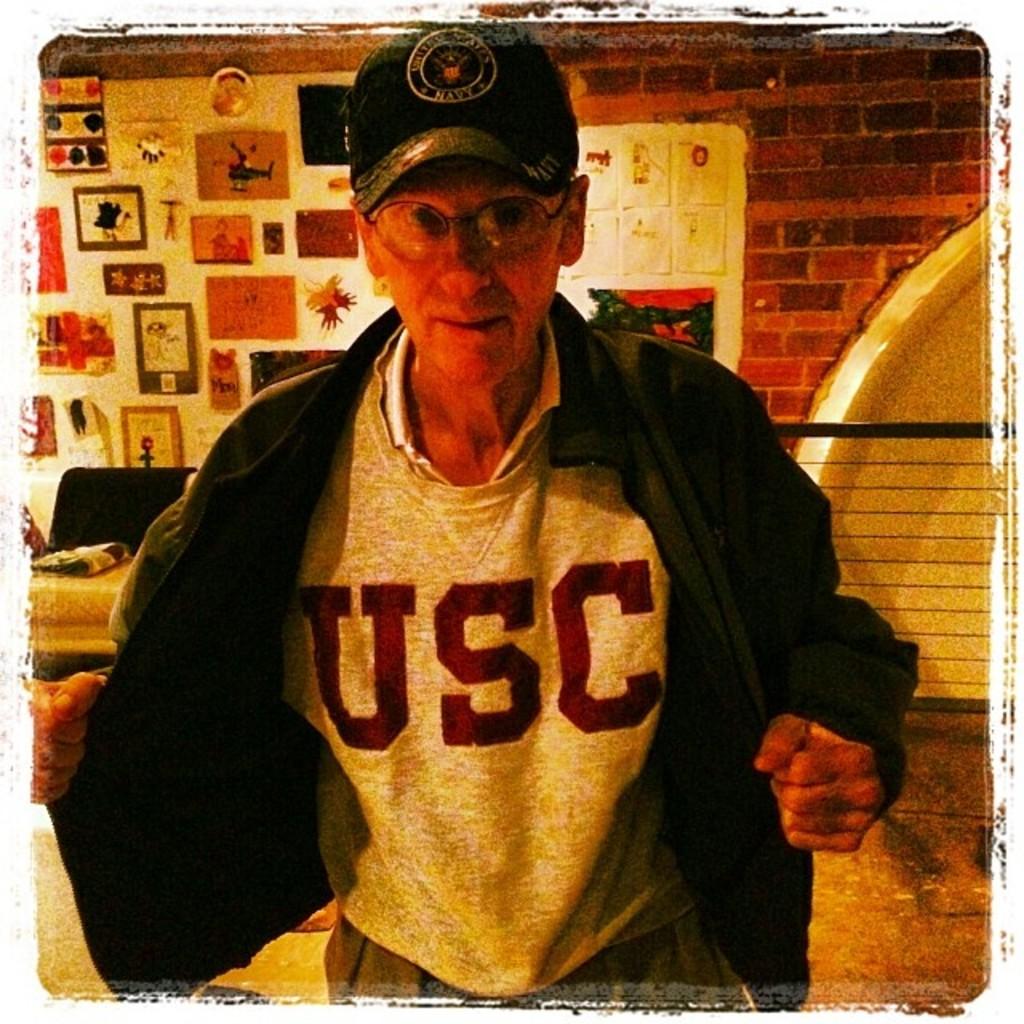What college is on that sweatshirt?
Your answer should be very brief. Usc. What military branch is on the man's hat?
Your response must be concise. Navy. 